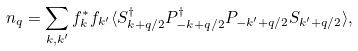Convert formula to latex. <formula><loc_0><loc_0><loc_500><loc_500>n _ { q } = \sum _ { k , k ^ { \prime } } f ^ { * } _ { k } f _ { k ^ { \prime } } \langle S ^ { \dag } _ { k + q / 2 } P ^ { \dag } _ { - k + q / 2 } P _ { - k ^ { \prime } + q / 2 } S _ { k ^ { \prime } + q / 2 } \rangle ,</formula> 